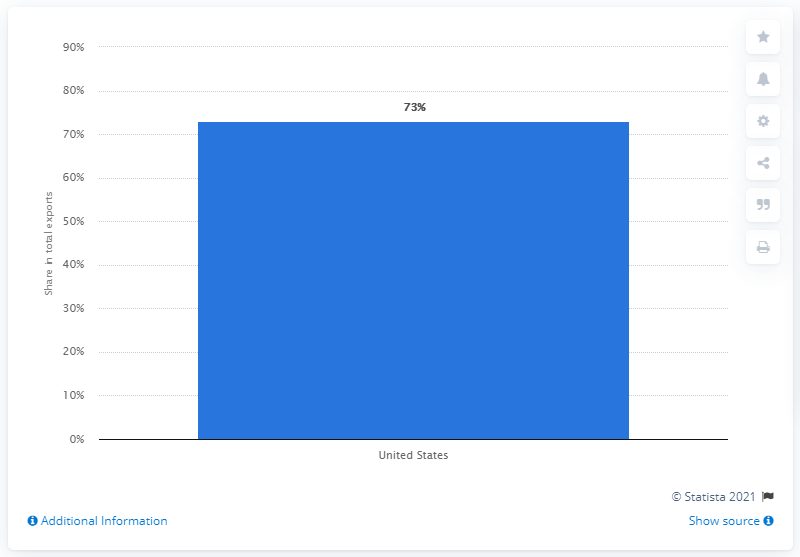Mention a couple of crucial points in this snapshot. In 2019, the United States was Canada's most important export partner, accounting for the majority of the country's total exports. 